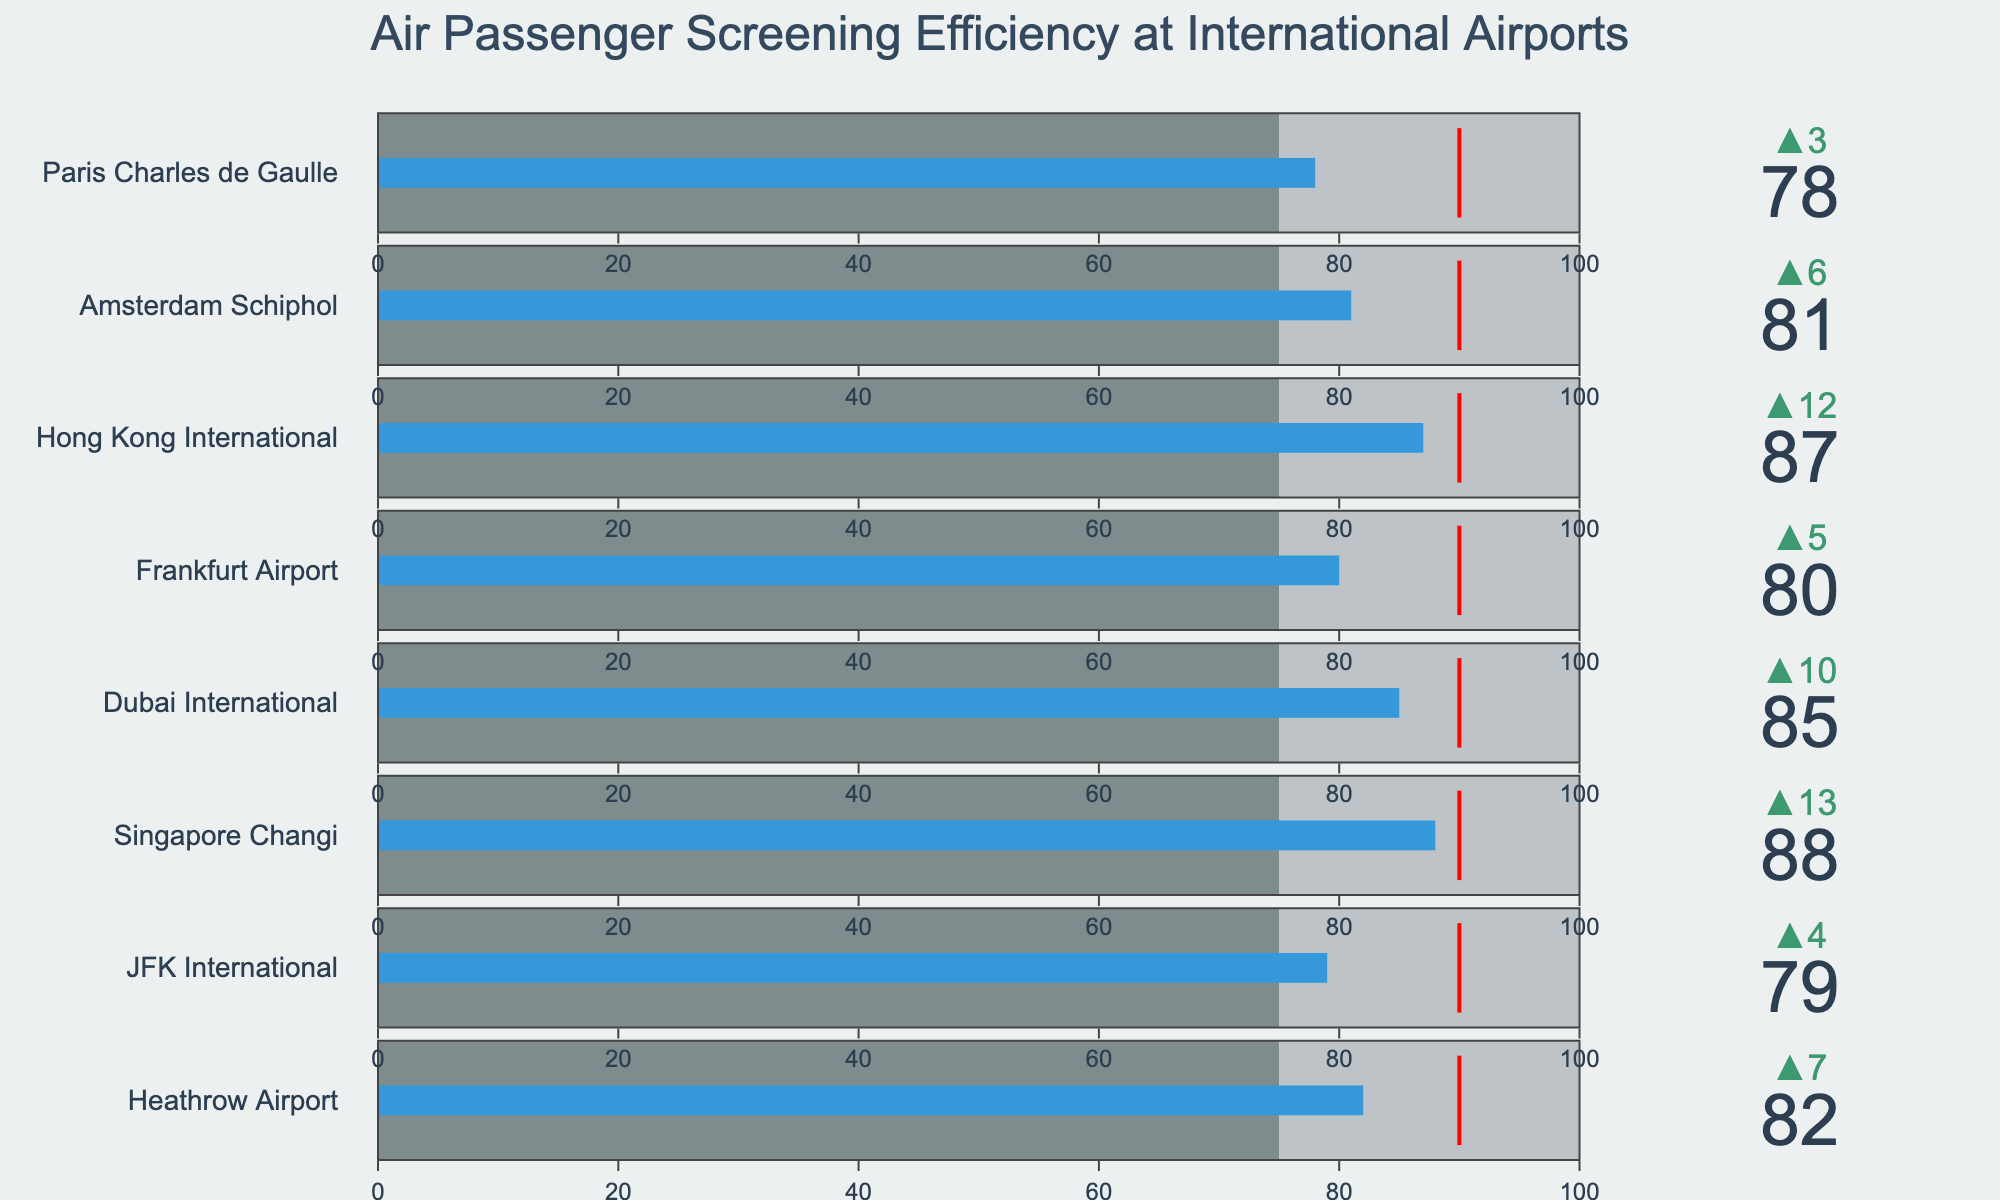What's the title of the chart? The title is given at the top of the chart. It reads "Air Passenger Screening Efficiency at International Airports".
Answer: Air Passenger Screening Efficiency at International Airports How many airports are compared in the figure? By counting the number of bullet charts (one per airport), you find there are a total of 8 airports compared in the figure.
Answer: 8 What is the screening efficiency of Singapore Changi Airport? The relevant value is shown in the bullet chart next to the title "Singapore Changi". The screening efficiency is 88%.
Answer: 88% Which airport has the lowest screening efficiency? By looking at the screening efficiency values for all the airports, Paris Charles de Gaulle has the lowest value, which is 78%.
Answer: Paris Charles de Gaulle How does Frankfurt Airport's screening efficiency compare to the national benchmark? Frankfurt Airport has a screening efficiency of 80%. The national benchmark is 75%. This means Frankfurt Airport exceeds the national benchmark by 5%.
Answer: Exceeds by 5% Which airport is closest to meeting the target screening efficiency of 90%? Among the listed screening efficiencies, Singapore Changi Airport with 88% is the closest to the target of 90%.
Answer: Singapore Changi How many airports have a screening efficiency greater than 85%? By checking each airport’s screening efficiency, the ones above 85% are Singapore Changi (88%), Dubai International (85%), and Hong Kong International (87%). There are 3 such airports.
Answer: 3 What is the average screening efficiency across all displayed airports? To find the average, sum up the efficiencies: 82 + 79 + 88 + 85 + 80 + 87 + 81 + 78 = 660. Then divide by the number of airports, 660/8 = 82.5%.
Answer: 82.5% Which airports have a screening efficiency that is exactly 85%? By looking at each bullet chart, Dubai International has a screening efficiency of exactly 85%.
Answer: Dubai International Is there any airport that has reached or exceeded the target efficiency of 90%? Based on the bullet charts and the target efficiency line, no airport has reached or exceeded the 90% target.
Answer: No 